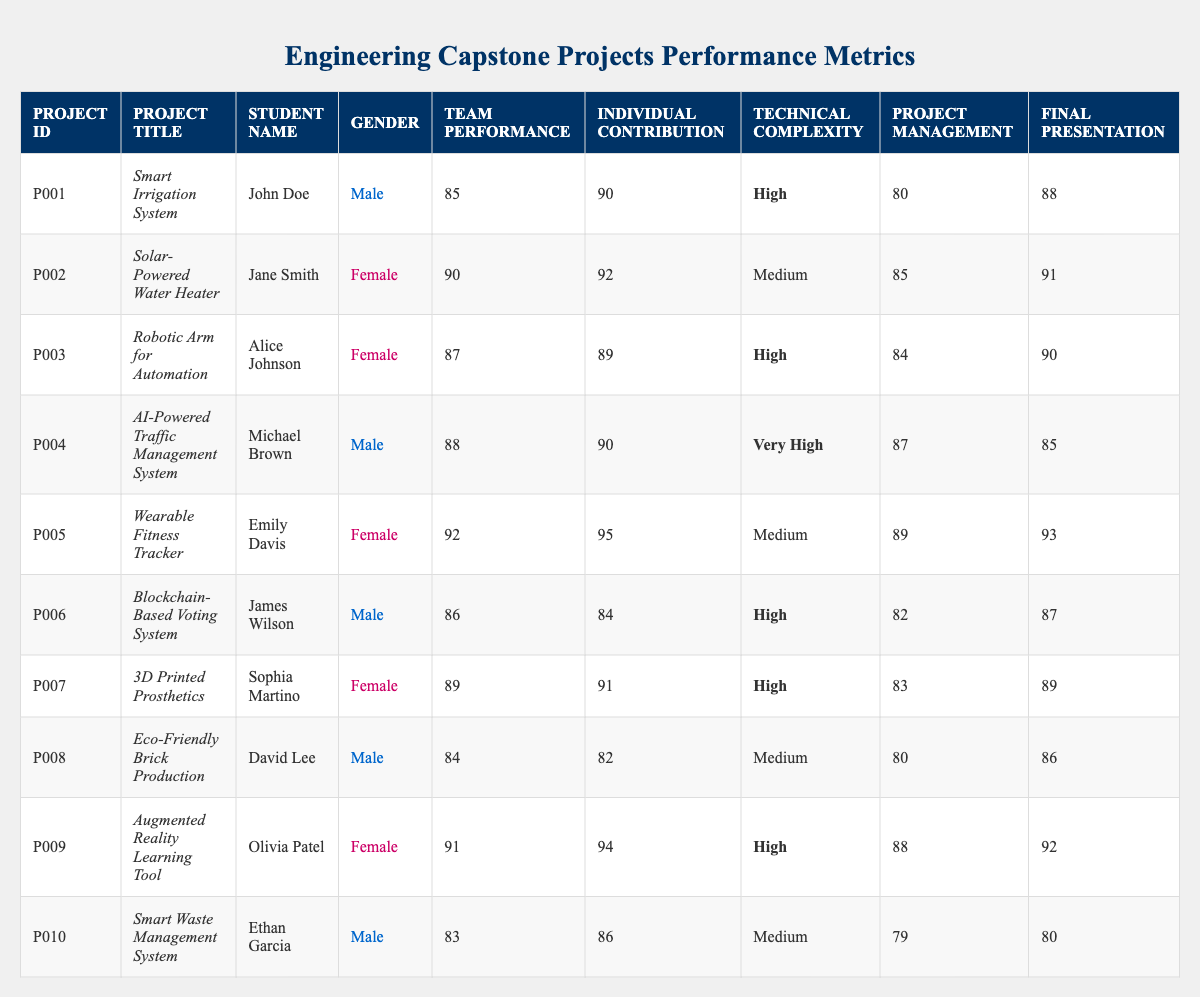What is the highest Team Performance Score among the projects? To find the highest Team Performance Score, I look at each score listed in the table. The scores are 85, 90, 87, 88, 92, 86, 89, 84, 91, and 83. The highest number among these is 92.
Answer: 92 How many male students participated in the capstone projects? I look through the Gender column in the table and count the number of entries that state 'Male.' The entries for males are John Doe, Michael Brown, James Wilson, David Lee, and Ethan Garcia, totaling 5 male students.
Answer: 5 What is the average Final Presentation Score for female students? I first locate the Final Presentation Scores for female students: 91, 90, 93, 89, and 92. Summing these scores gives 91 + 90 + 93 + 89 + 92 = 455. There are 5 female students, so the average is 455 / 5 = 91.
Answer: 91 Did any male students have a Team Performance Score higher than 90? I examine the Team Performance Scores for male students: 85, 88, 86, 84, and 83. None of these scores exceed 90, which means the answer is no.
Answer: No Which project had the highest Individual Contribution Score, and what was it? I review the Individual Contribution Scores for all projects: 90, 92, 89, 90, 95, 84, 91, 82, 94, and 86. The highest score among these is 95, which belongs to the project "Wearable Fitness Tracker" by Emily Davis.
Answer: Wearable Fitness Tracker, 95 What is the difference in Team Performance Score between the highest and lowest scoring projects? The highest Team Performance Score is 92 (Wearable Fitness Tracker), and the lowest is 83 (Smart Waste Management System). The difference is calculated as 92 - 83 = 9.
Answer: 9 How many projects had a Technical Complexity level of 'High'? I identify the projects with 'High' in the Technical Complexity column: Smart Irrigation System, Robotic Arm for Automation, Blockchain-Based Voting System, 3D Printed Prosthetics, and Augmented Reality Learning Tool. There are 5 such projects in total.
Answer: 5 What is the total score for Project Management for all female students? First, I find the Project Management Scores for female students, which are 85, 84, 89, 83, and 88. Summing these gives 85 + 84 + 89 + 83 + 88 = 429.
Answer: 429 Which gender had a project with the most complex technical challenges? I examine the Technical Complexity levels. The project "AI-Powered Traffic Management System" by a male student has a Technical Complexity of 'Very High.' Therefore, the gender is male.
Answer: Male Are the Final Presentation Scores for all male students above 80? I look at the Final Presentation Scores for male students: 88, 85, 87, 86, and 80. The score of 80 is not above 80, making the answer no.
Answer: No 